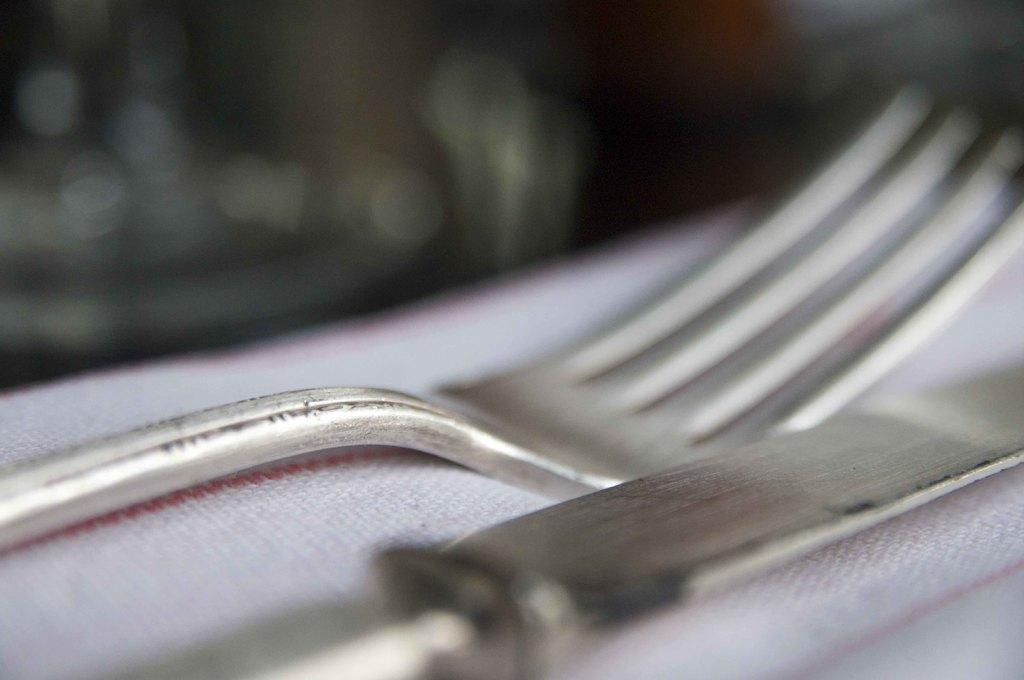What utensils can be seen in the image? There is a knife and a fork in the image. Can you describe the focus of the image? The foreground of the image is clear, while the background is blurry. What time of day is it in the image, and how can you tell? The time of day cannot be determined from the image, as there are no clues or context provided. 